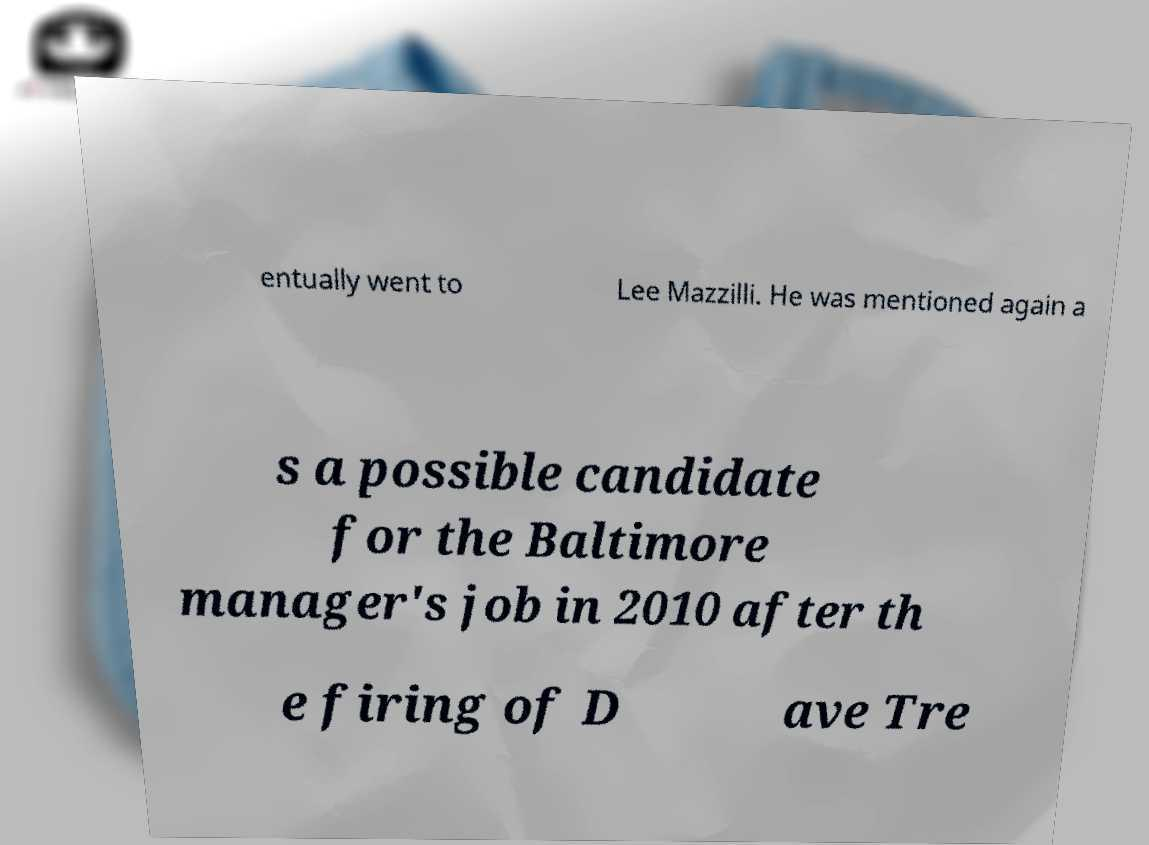There's text embedded in this image that I need extracted. Can you transcribe it verbatim? entually went to Lee Mazzilli. He was mentioned again a s a possible candidate for the Baltimore manager's job in 2010 after th e firing of D ave Tre 